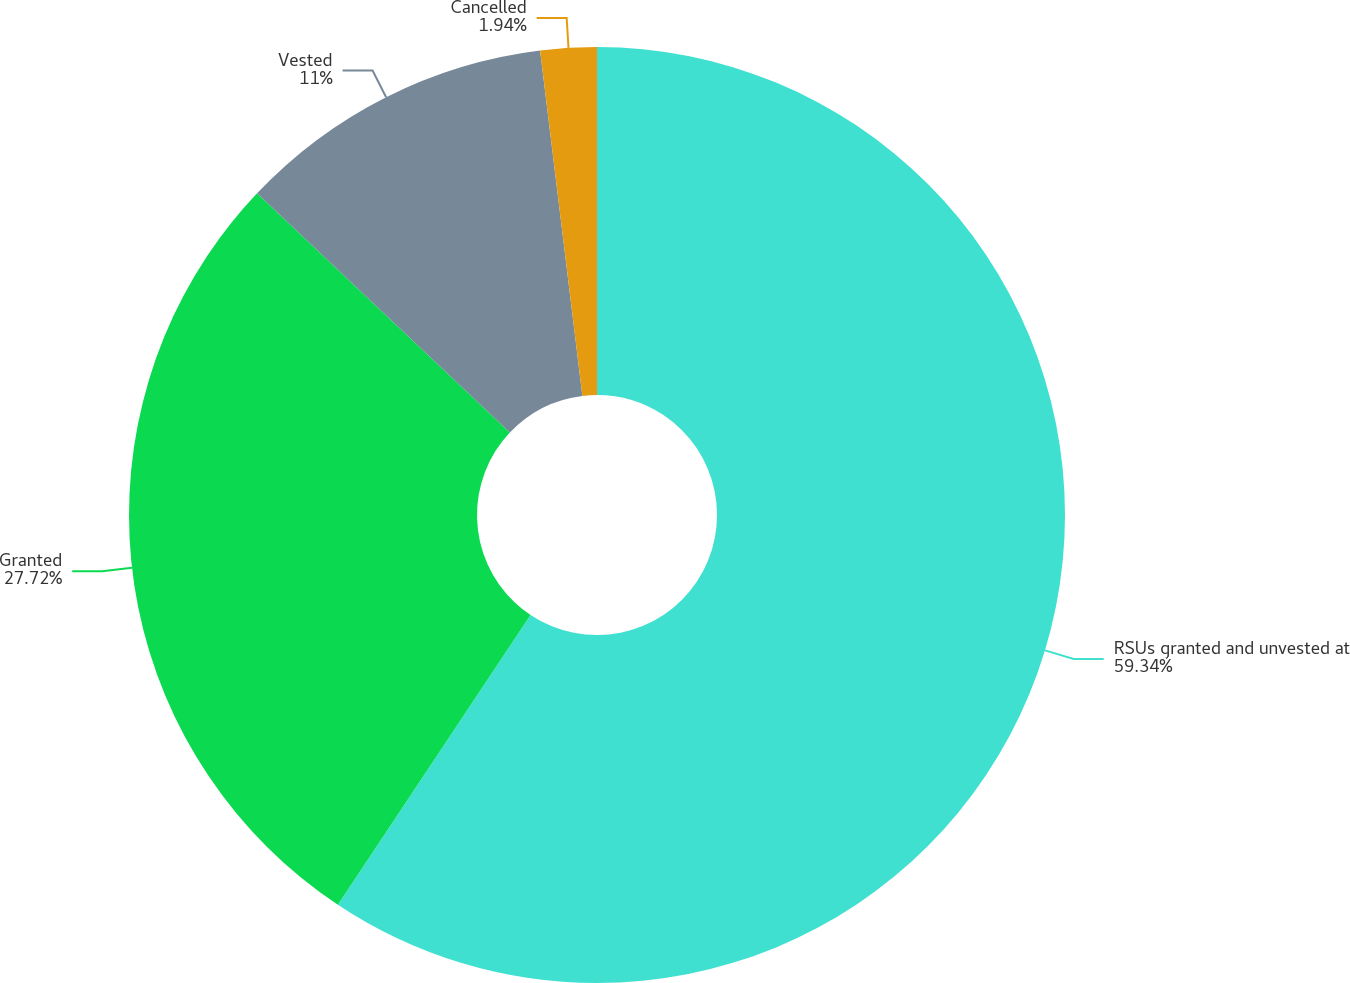Convert chart to OTSL. <chart><loc_0><loc_0><loc_500><loc_500><pie_chart><fcel>RSUs granted and unvested at<fcel>Granted<fcel>Vested<fcel>Cancelled<nl><fcel>59.34%<fcel>27.72%<fcel>11.0%<fcel>1.94%<nl></chart> 